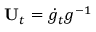<formula> <loc_0><loc_0><loc_500><loc_500>U _ { t } = \dot { g } _ { t } g ^ { - 1 }</formula> 